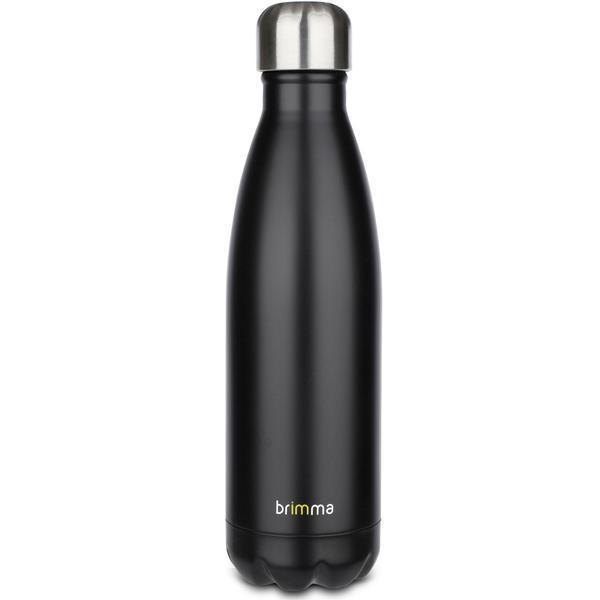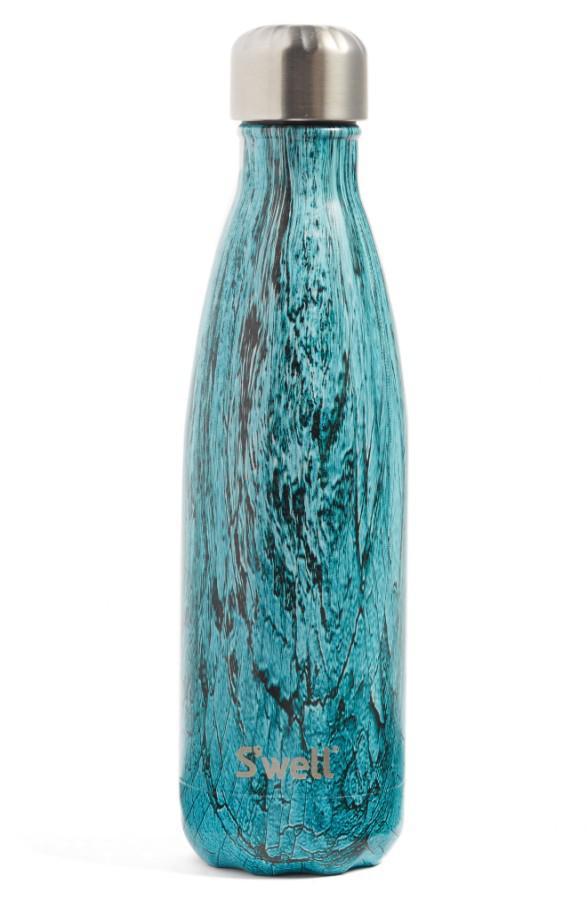The first image is the image on the left, the second image is the image on the right. Analyze the images presented: Is the assertion "There are stainless steel water bottles that are all solid colored." valid? Answer yes or no. No. 